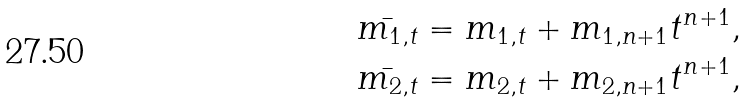Convert formula to latex. <formula><loc_0><loc_0><loc_500><loc_500>& \bar { m _ { 1 , t } } = m _ { 1 , t } + m _ { 1 , n + 1 } t ^ { n + 1 } , \\ & \bar { m _ { 2 , t } } = m _ { 2 , t } + m _ { 2 , n + 1 } t ^ { n + 1 } ,</formula> 